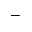<formula> <loc_0><loc_0><loc_500><loc_500>-</formula> 